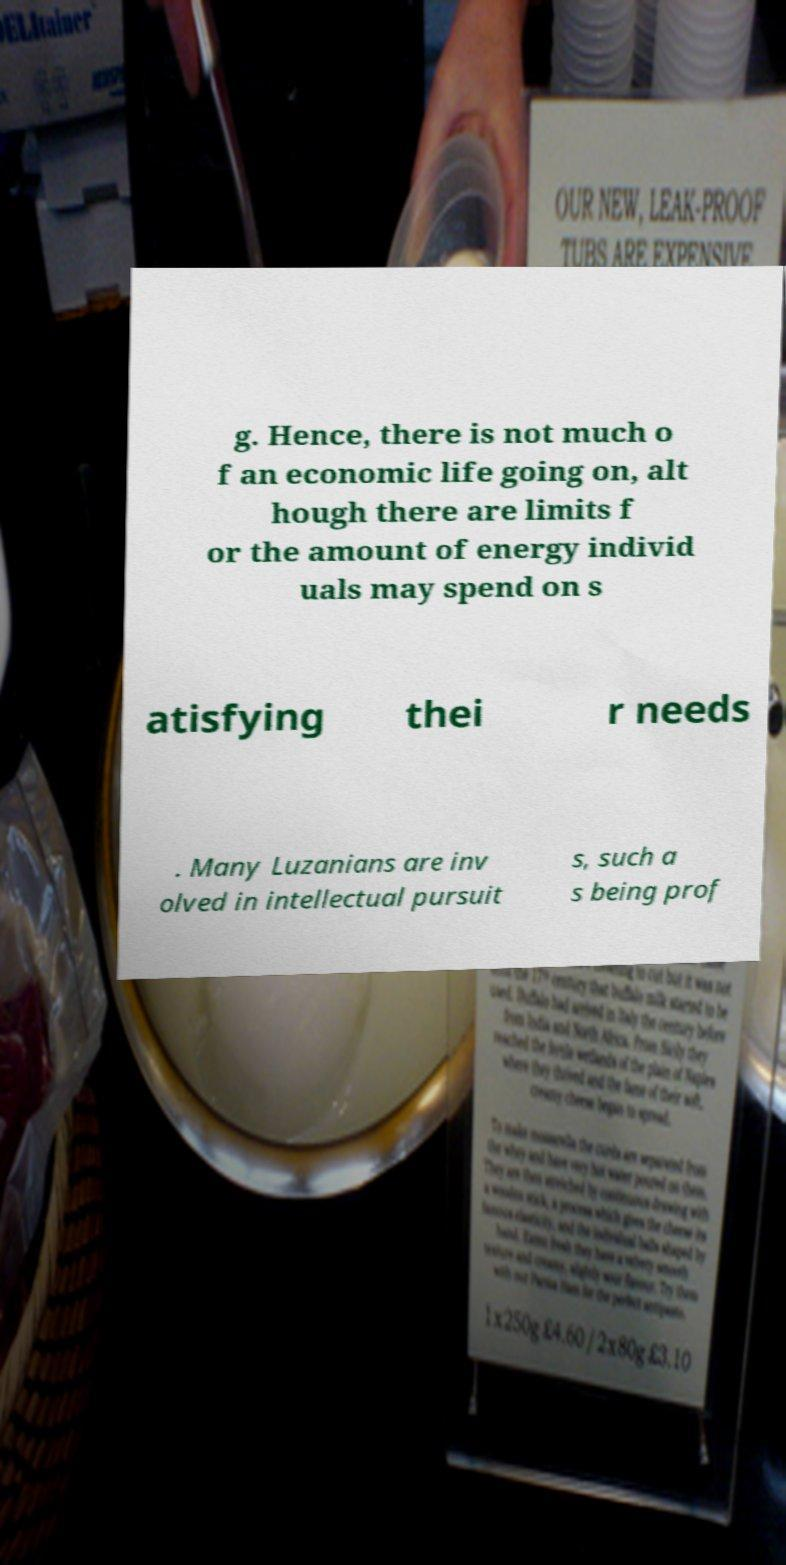For documentation purposes, I need the text within this image transcribed. Could you provide that? g. Hence, there is not much o f an economic life going on, alt hough there are limits f or the amount of energy individ uals may spend on s atisfying thei r needs . Many Luzanians are inv olved in intellectual pursuit s, such a s being prof 